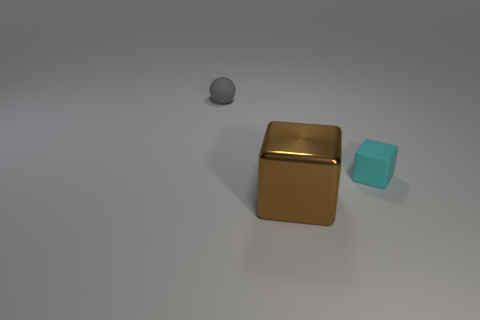Add 1 tiny rubber things. How many objects exist? 4 Subtract all spheres. How many objects are left? 2 Add 2 gray balls. How many gray balls exist? 3 Subtract 0 green blocks. How many objects are left? 3 Subtract all cyan things. Subtract all gray balls. How many objects are left? 1 Add 3 gray matte balls. How many gray matte balls are left? 4 